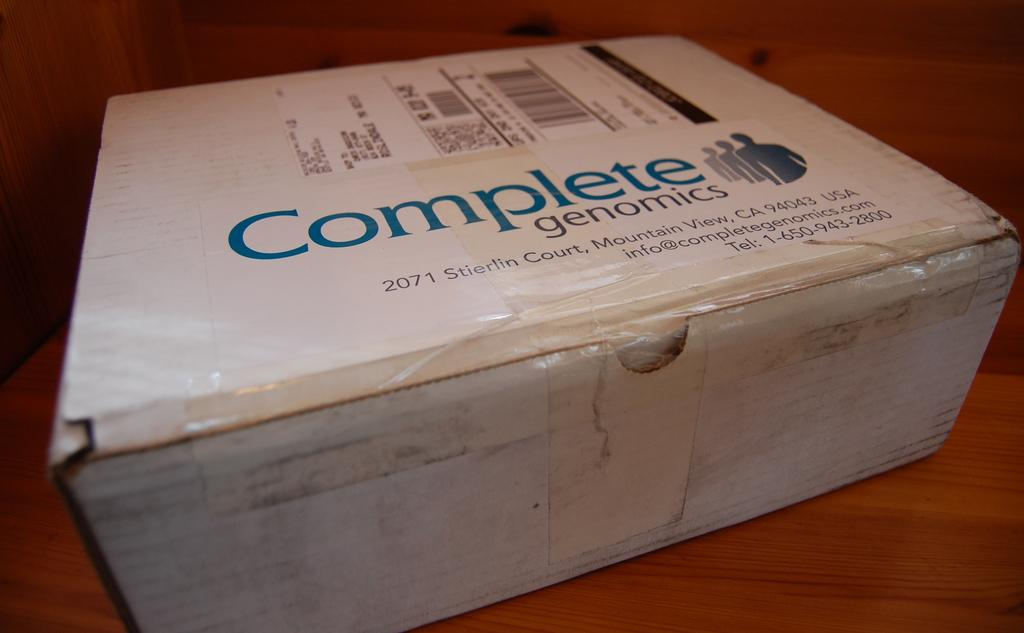Provide a one-sentence caption for the provided image. A BOX WITH A PREPAID LABEL ON IT NEXT TO A LABEL THAT SAYS 'COMPLETE genomics". 